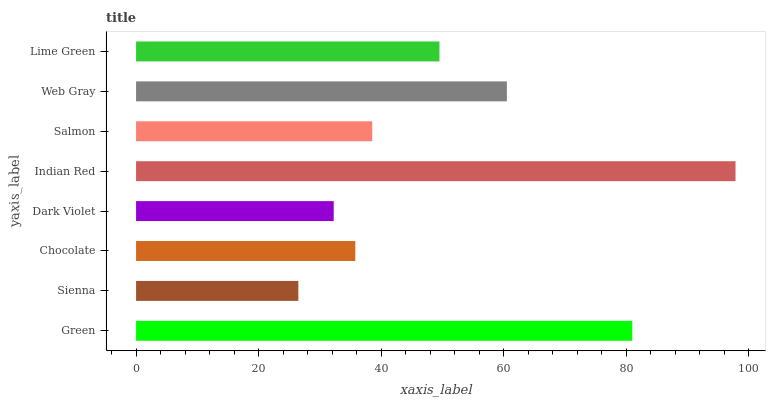Is Sienna the minimum?
Answer yes or no. Yes. Is Indian Red the maximum?
Answer yes or no. Yes. Is Chocolate the minimum?
Answer yes or no. No. Is Chocolate the maximum?
Answer yes or no. No. Is Chocolate greater than Sienna?
Answer yes or no. Yes. Is Sienna less than Chocolate?
Answer yes or no. Yes. Is Sienna greater than Chocolate?
Answer yes or no. No. Is Chocolate less than Sienna?
Answer yes or no. No. Is Lime Green the high median?
Answer yes or no. Yes. Is Salmon the low median?
Answer yes or no. Yes. Is Salmon the high median?
Answer yes or no. No. Is Web Gray the low median?
Answer yes or no. No. 